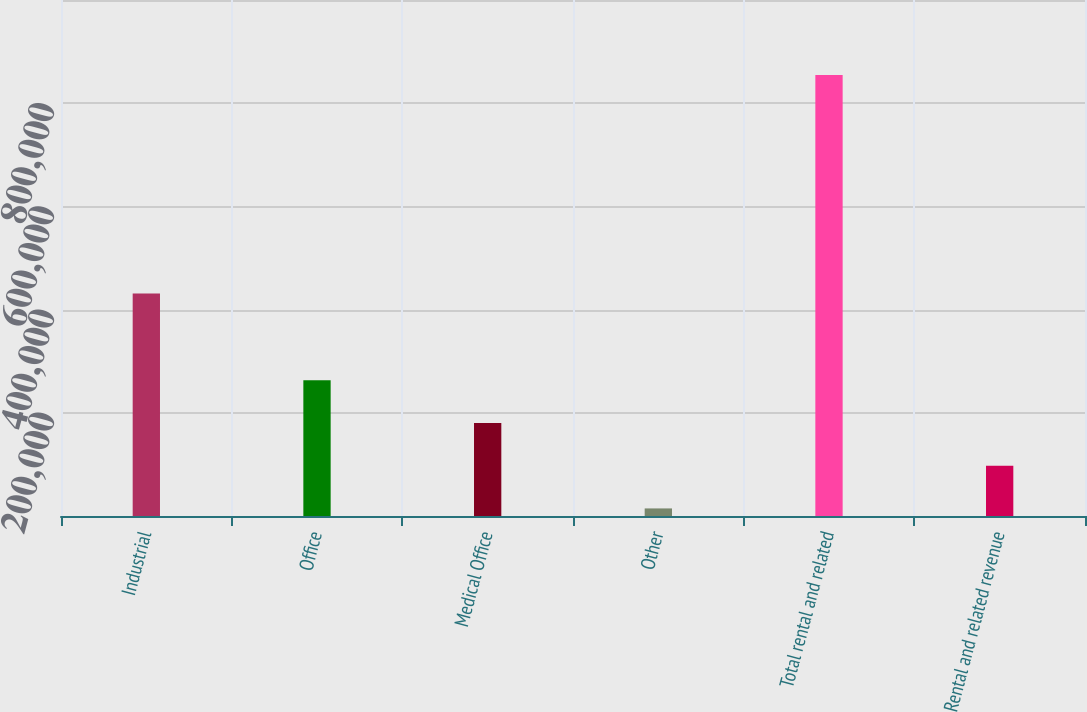Convert chart. <chart><loc_0><loc_0><loc_500><loc_500><bar_chart><fcel>Industrial<fcel>Office<fcel>Medical Office<fcel>Other<fcel>Total rental and related<fcel>Rental and related revenue<nl><fcel>431277<fcel>263063<fcel>180264<fcel>14667<fcel>854424<fcel>97465.6<nl></chart> 